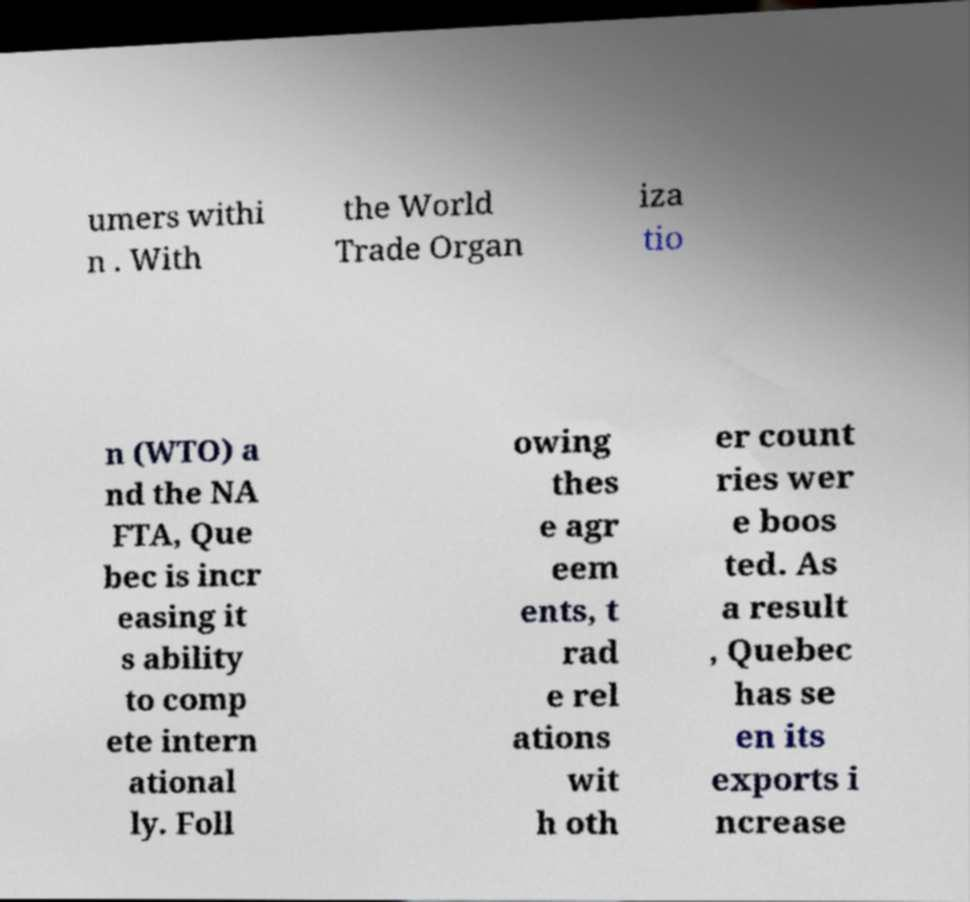Please identify and transcribe the text found in this image. umers withi n . With the World Trade Organ iza tio n (WTO) a nd the NA FTA, Que bec is incr easing it s ability to comp ete intern ational ly. Foll owing thes e agr eem ents, t rad e rel ations wit h oth er count ries wer e boos ted. As a result , Quebec has se en its exports i ncrease 